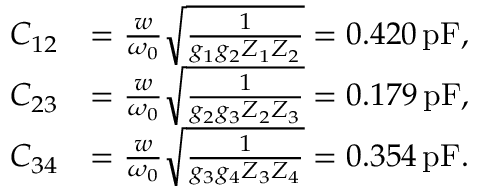Convert formula to latex. <formula><loc_0><loc_0><loc_500><loc_500>\begin{array} { r l } { C _ { 1 2 } } & { = \frac { w } { \omega _ { 0 } } \sqrt { \frac { 1 } { g _ { 1 } g _ { 2 } Z _ { 1 } Z _ { 2 } } } = 0 . 4 2 0 \, p F , } \\ { C _ { 2 3 } } & { = \frac { w } { \omega _ { 0 } } \sqrt { \frac { 1 } { g _ { 2 } g _ { 3 } Z _ { 2 } Z _ { 3 } } } = 0 . 1 7 9 \, p F , } \\ { C _ { 3 4 } } & { = \frac { w } { \omega _ { 0 } } \sqrt { \frac { 1 } { g _ { 3 } g _ { 4 } Z _ { 3 } Z _ { 4 } } } = 0 . 3 5 4 \, p F . } \end{array}</formula> 